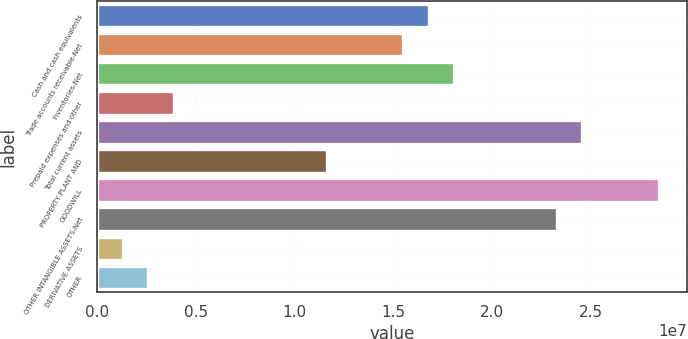Convert chart to OTSL. <chart><loc_0><loc_0><loc_500><loc_500><bar_chart><fcel>Cash and cash equivalents<fcel>Trade accounts receivable-Net<fcel>Inventories-Net<fcel>Prepaid expenses and other<fcel>Total current assets<fcel>PROPERTY PLANT AND<fcel>GOODWILL<fcel>OTHER INTANGIBLE ASSETS-Net<fcel>DERIVATIVE ASSETS<fcel>OTHER<nl><fcel>1.68048e+07<fcel>1.55121e+07<fcel>1.80974e+07<fcel>3.87845e+06<fcel>2.45605e+07<fcel>1.16342e+07<fcel>2.84384e+07<fcel>2.32679e+07<fcel>1.29319e+06<fcel>2.58582e+06<nl></chart> 